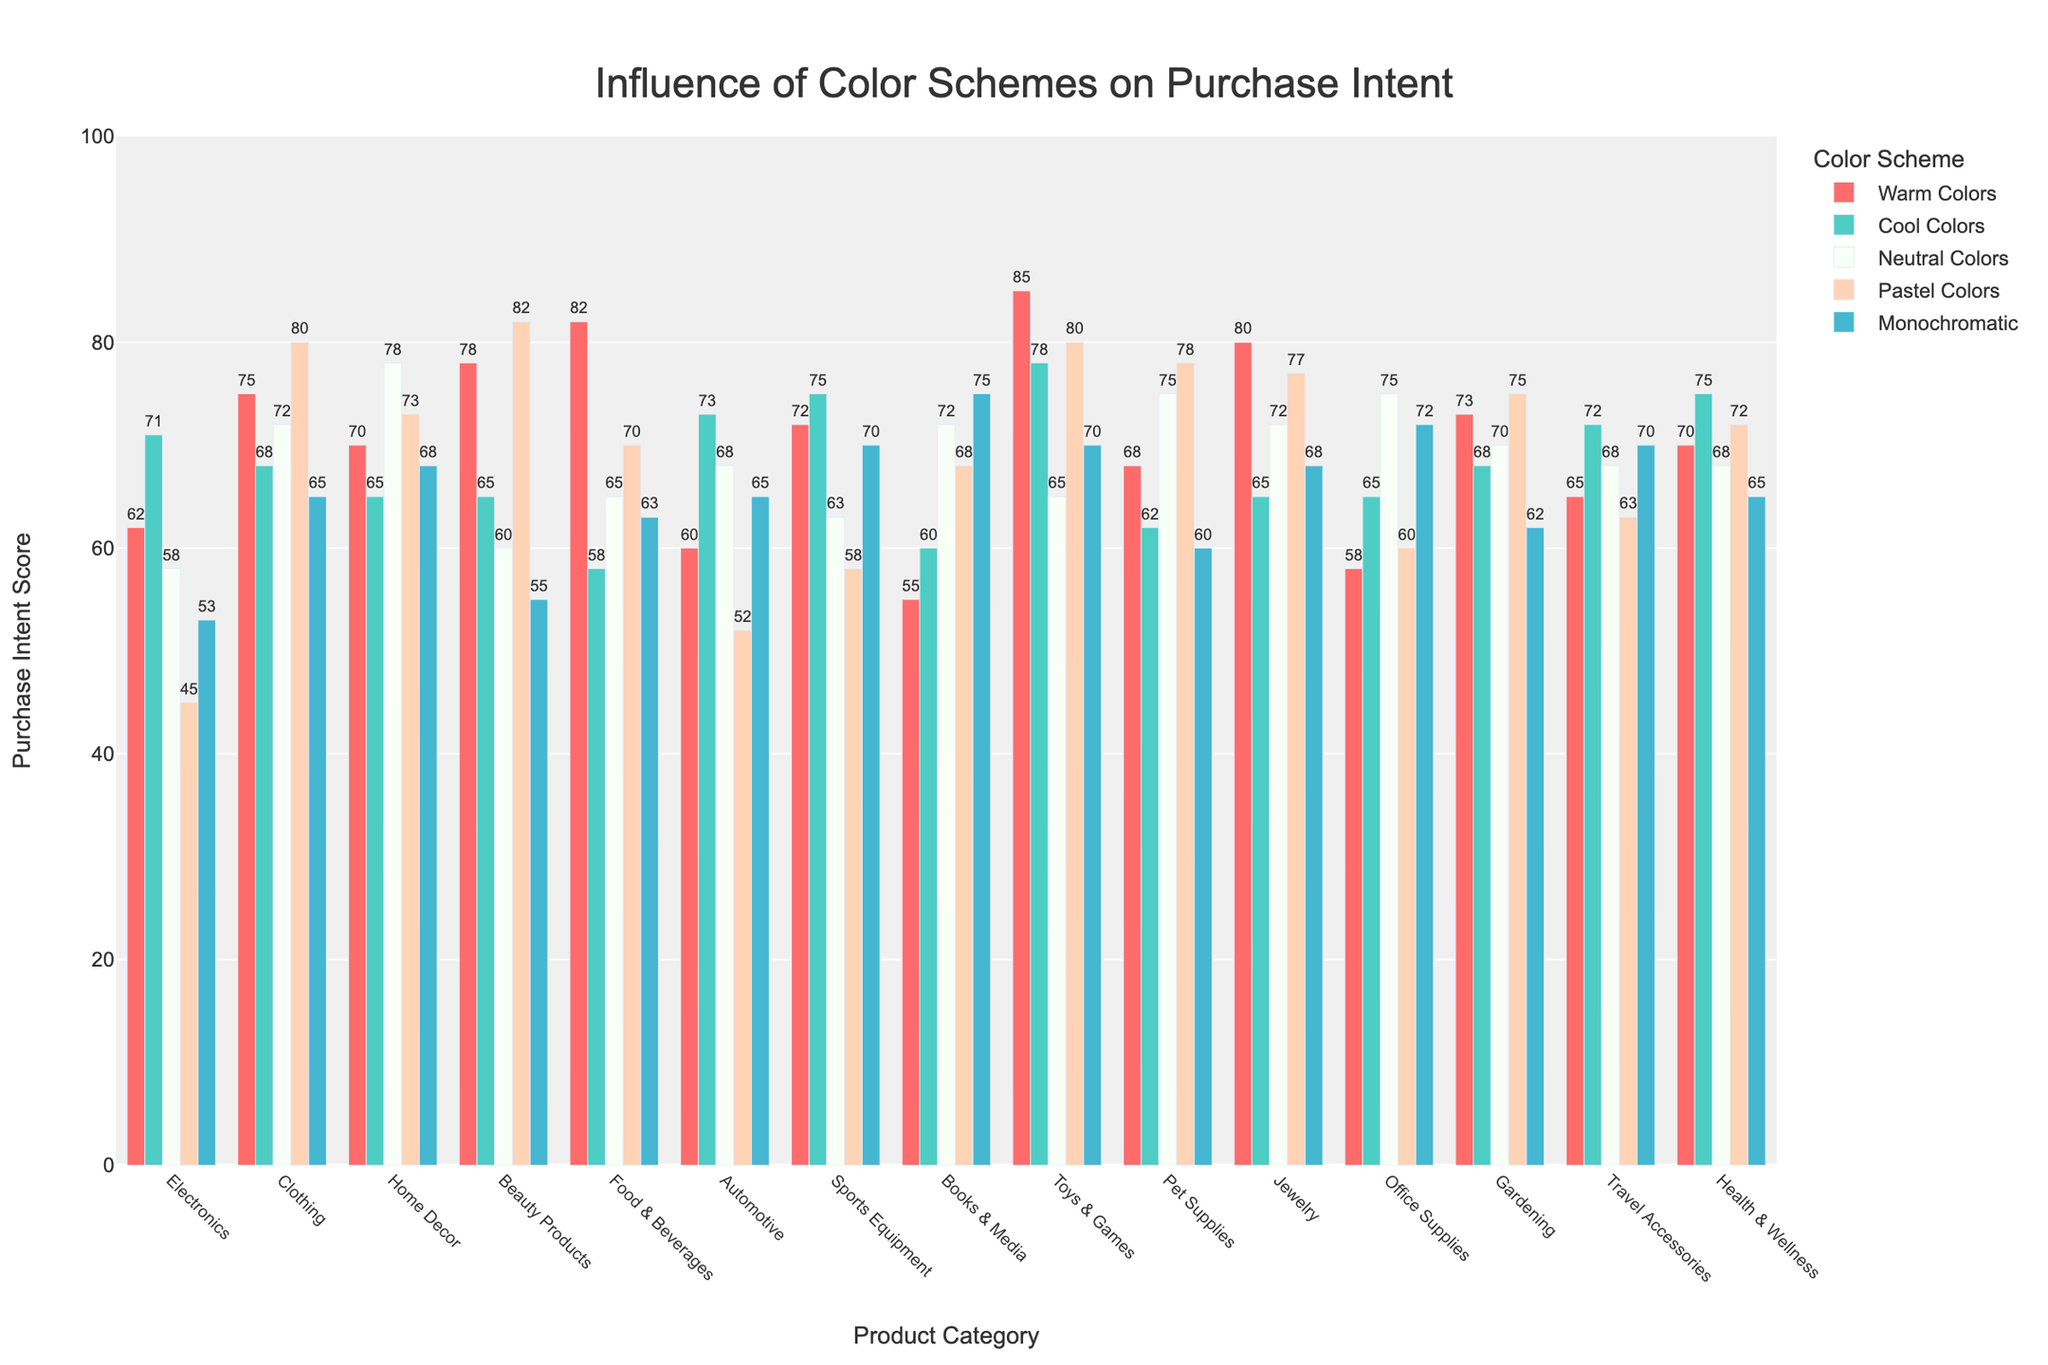Which product category has the highest purchase intent score for warm colors? Look for the bar with the highest value for warm colors among all product categories. The bar for "Toys & Games" reaches the highest point at 85.
Answer: Toys & Games What are the two product categories with the highest purchase intent scores for pastel colors combined? Identify the pastel colors bars for all product categories, then sum the values for the highest two. The highest scores are "Beauty Products" (82) and "Toys & Games" (80). 82 + 80 = 162
Answer: Beauty Products, Toys & Games Which color scheme has the least impact on purchase intent for Electronics? Compare the bars for Electronics. The pastel colors bar has the lowest value of 45.
Answer: Pastel Colors Are there any product categories where neutral colors have the highest purchase intent score compared to other color schemes? Identify which product categories have the highest bar for neutral colors. The product categories are "Home Decor", "Books & Media", "Pet Supplies", and "Office Supplies".
Answer: Home Decor, Books & Media, Pet Supplies, Office Supplies What is the difference in purchase intent scores between warm colors and monochromatic color schemes for Health & Wellness? Find the bars for Health & Wellness for warm colors and monochromatic; their values are 70 and 65 respectively. The difference is 70 - 65 = 5.
Answer: 5 Which category has the most visually similar purchase intent scores across all color schemes? Look for small differences between the lengths of bars for each product category. "Automotive" has values close to each other: 60, 73, 68, 52, 65.
Answer: Automotive What is the average purchase intent score for cool colors across all product categories? Add all the cool colors scores (71 + 68 + 65 + 65 + 58 + 73 + 75 + 60 + 78 + 62 + 65 + 65 + 68 + 72 + 75 = 1010). Divide by the number of categories (15). 1010 / 15 = approx. 67.33.
Answer: 67.33 Which product category shows the greatest difference between its highest and lowest purchase intent scores? Calculate the range of values for each product category and find the maximum range. "Food & Beverages" has the greatest difference: 82 (warm colors) - 58 (cool colors) = 24.
Answer: Food & Beverages Do any product categories have an equal purchase intent score for any two color schemes? Check for equal heights among the bars for each product category. "Gardening" has equal purchase intent scores for neutral and pastel colors (both 70).
Answer: Gardening Is there a product category where monochromatic color schemes have the highest purchase intent score? Check each product category to see if monochromatic bar is the highest. "Books & Media" has 75 for monochromatic, which is the highest among its scores.
Answer: Books & Media 